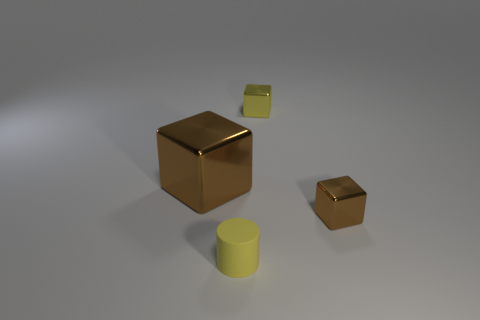Is there any other thing that is the same size as the cylinder?
Your answer should be compact. Yes. There is a yellow matte cylinder; is it the same size as the object behind the large brown metallic thing?
Ensure brevity in your answer.  Yes. The tiny yellow object that is behind the tiny brown thing has what shape?
Provide a short and direct response. Cube. There is a metal cube in front of the object left of the tiny yellow matte thing; what is its color?
Offer a very short reply. Brown. What is the color of the big metal object that is the same shape as the small brown metal object?
Offer a very short reply. Brown. What number of tiny shiny objects have the same color as the tiny rubber cylinder?
Provide a short and direct response. 1. Does the large cube have the same color as the tiny metal thing in front of the yellow metallic object?
Keep it short and to the point. Yes. What shape is the tiny object that is in front of the large brown metallic cube and behind the matte cylinder?
Keep it short and to the point. Cube. What material is the small object behind the brown object that is to the left of the brown block right of the small rubber cylinder made of?
Your response must be concise. Metal. Are there more big brown things that are to the right of the tiny brown metallic block than metallic cubes that are in front of the big block?
Provide a succinct answer. No. 